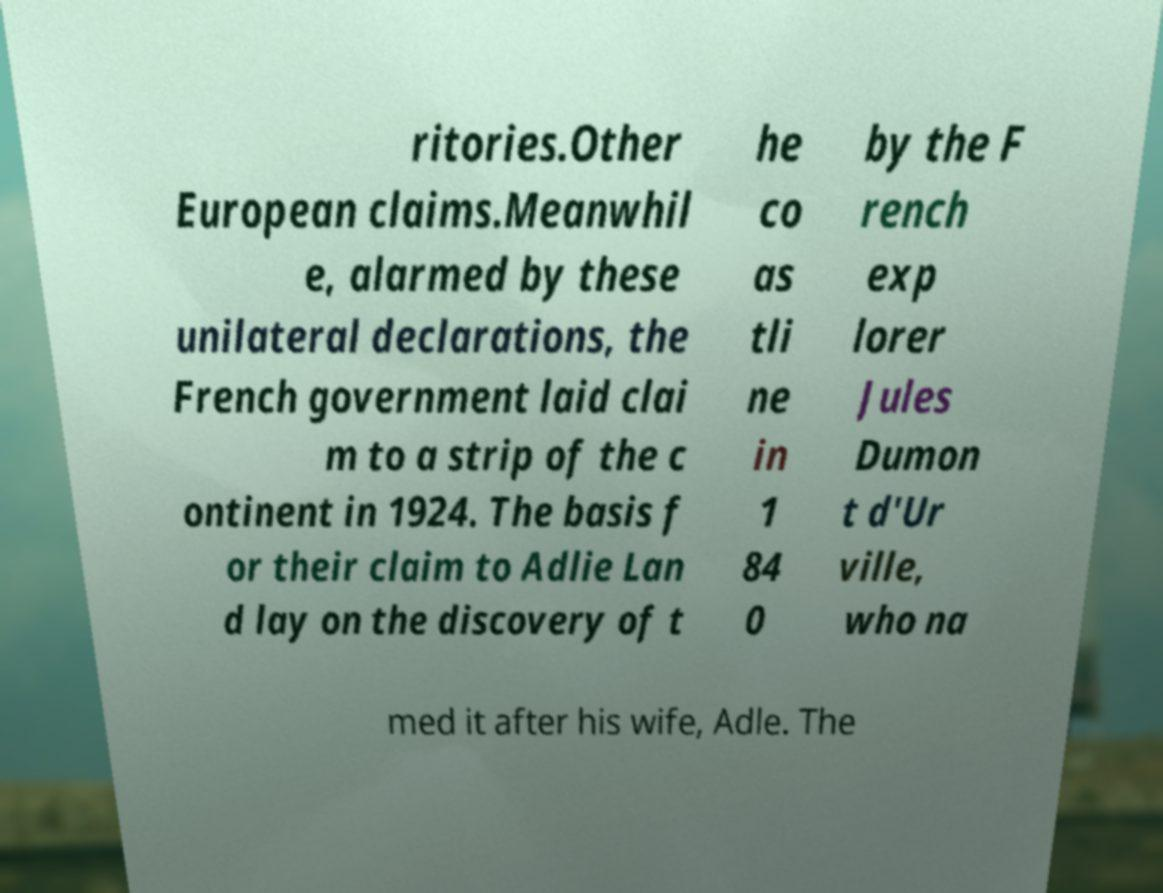There's text embedded in this image that I need extracted. Can you transcribe it verbatim? ritories.Other European claims.Meanwhil e, alarmed by these unilateral declarations, the French government laid clai m to a strip of the c ontinent in 1924. The basis f or their claim to Adlie Lan d lay on the discovery of t he co as tli ne in 1 84 0 by the F rench exp lorer Jules Dumon t d'Ur ville, who na med it after his wife, Adle. The 